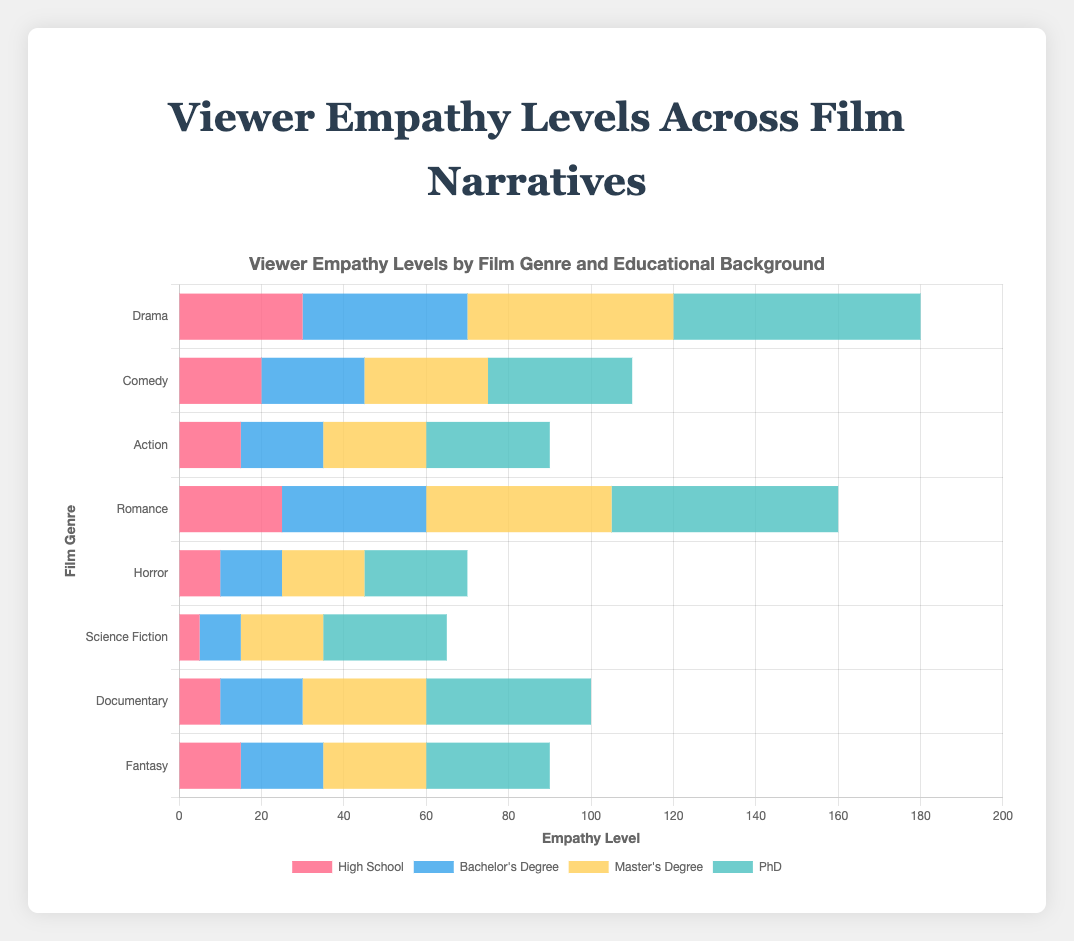Which film genre has the highest empathy level for viewers with a PhD? According to the figure, for viewers with a PhD, the bar representing Drama reaches the highest empathy level.
Answer: Drama How does the empathy level for Science Fiction compare between viewers with a High School education and viewers with a Bachelor's Degree? The empathy level for Science Fiction is 5 for High School and 10 for Bachelor's Degree, so viewers with a Bachelor's Degree have a higher empathy level.
Answer: Bachelor's Degree is higher What is the combined empathy level for viewers with a Master's Degree across Action and Fantasy films? The empathy level for Master's Degree viewers is 25 for Action and 25 for Fantasy. Adding these values gives 25 + 25.
Answer: 50 Which educational background category shows the most consistent empathy levels across all film genres? Reviewing the length of the bars for each educational background category across all film genres, viewers with a PhD have more consistent levels as there is less variability.
Answer: PhD Comparing Comedy and Romance films, which film genre elicits higher empathy from viewers with a Bachelor's Degree and by what difference? For viewers with a Bachelor's Degree, the empathy level is 25 for Comedy and 35 for Romance. The difference is 35 - 25.
Answer: Romance by 10 points Which film genre shows the least empathy level from viewers with a High School education? The shortest bar for viewers with a High School education belongs to Science Fiction, with an empathy level of 5.
Answer: Science Fiction For viewers with a Master's Degree, which genre has the lowest empathy level, and how much lower is it compared to the highest empathy level in this category? The lowest empathy level for Master's Degree viewers is 20 for Horror, while the highest is 50 for Drama. The difference is 50 - 20.
Answer: Horror, 30 points What is the average empathy level for viewers with a Bachelor's Degree across Documentary and Horror films? The empathy level for Bachelor's Degree viewers is 20 for Documentary and 15 for Horror. The average is (20 + 15) / 2.
Answer: 17.5 In the category of viewers with a Bachelor's Degree, what's the total empathy level for Drama, Comedy, and Action films combined? Summing the empathy levels for Drama (40), Comedy (25), and Action (20) gives 40 + 25 + 20.
Answer: 85 Which film genre has the widest range of empathy levels across different educational backgrounds? To determine the widest range, subtract the lowest empathy level from the highest for each film genre. Drama has the widest range from 30 (High School) to 60 (PhD), giving a range of 60 - 30.
Answer: Drama 